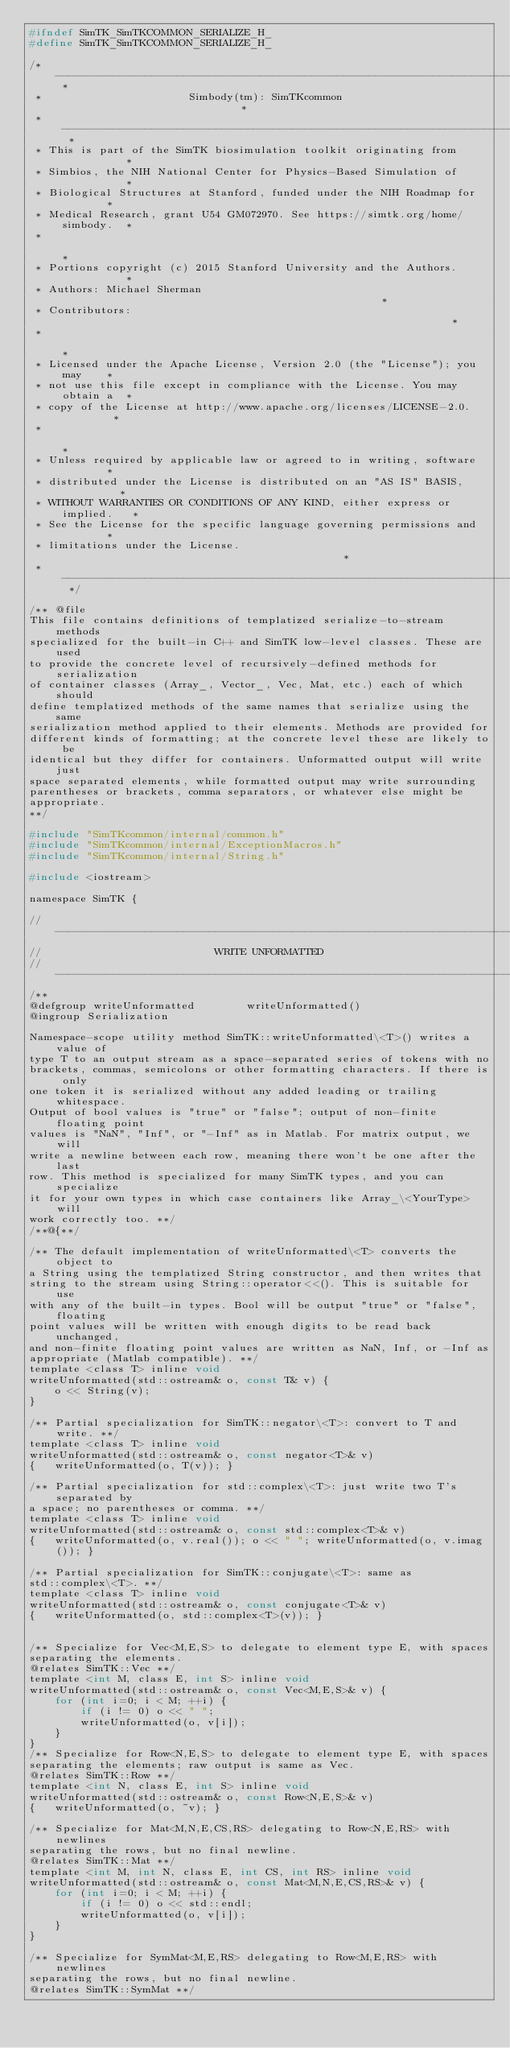<code> <loc_0><loc_0><loc_500><loc_500><_C_>#ifndef SimTK_SimTKCOMMON_SERIALIZE_H_
#define SimTK_SimTKCOMMON_SERIALIZE_H_

/* -------------------------------------------------------------------------- *
 *                       Simbody(tm): SimTKcommon                             *
 * -------------------------------------------------------------------------- *
 * This is part of the SimTK biosimulation toolkit originating from           *
 * Simbios, the NIH National Center for Physics-Based Simulation of           *
 * Biological Structures at Stanford, funded under the NIH Roadmap for        *
 * Medical Research, grant U54 GM072970. See https://simtk.org/home/simbody.  *
 *                                                                            *
 * Portions copyright (c) 2015 Stanford University and the Authors.           *
 * Authors: Michael Sherman                                                   *
 * Contributors:                                                              *
 *                                                                            *
 * Licensed under the Apache License, Version 2.0 (the "License"); you may    *
 * not use this file except in compliance with the License. You may obtain a  *
 * copy of the License at http://www.apache.org/licenses/LICENSE-2.0.         *
 *                                                                            *
 * Unless required by applicable law or agreed to in writing, software        *
 * distributed under the License is distributed on an "AS IS" BASIS,          *
 * WITHOUT WARRANTIES OR CONDITIONS OF ANY KIND, either express or implied.   *
 * See the License for the specific language governing permissions and        *
 * limitations under the License.                                             *
 * -------------------------------------------------------------------------- */

/** @file
This file contains definitions of templatized serialize-to-stream methods 
specialized for the built-in C++ and SimTK low-level classes. These are used
to provide the concrete level of recursively-defined methods for serialization
of container classes (Array_, Vector_, Vec, Mat, etc.) each of which should
define templatized methods of the same names that serialize using the same
serialization method applied to their elements. Methods are provided for 
different kinds of formatting; at the concrete level these are likely to be
identical but they differ for containers. Unformatted output will write just
space separated elements, while formatted output may write surrounding
parentheses or brackets, comma separators, or whatever else might be 
appropriate.
**/

#include "SimTKcommon/internal/common.h"
#include "SimTKcommon/internal/ExceptionMacros.h"
#include "SimTKcommon/internal/String.h"

#include <iostream>

namespace SimTK {

//------------------------------------------------------------------------------
//                           WRITE UNFORMATTED
//------------------------------------------------------------------------------
/**
@defgroup writeUnformatted        writeUnformatted()
@ingroup Serialization

Namespace-scope utility method SimTK::writeUnformatted\<T>() writes a value of
type T to an output stream as a space-separated series of tokens with no 
brackets, commas, semicolons or other formatting characters. If there is only 
one token it is serialized without any added leading or trailing whitespace.
Output of bool values is "true" or "false"; output of non-finite floating point
values is "NaN", "Inf", or "-Inf" as in Matlab. For matrix output, we will 
write a newline between each row, meaning there won't be one after the last 
row. This method is specialized for many SimTK types, and you can specialize
it for your own types in which case containers like Array_\<YourType> will 
work correctly too. **/
/**@{**/

/** The default implementation of writeUnformatted\<T> converts the object to
a String using the templatized String constructor, and then writes that
string to the stream using String::operator<<(). This is suitable for use
with any of the built-in types. Bool will be output "true" or "false", floating
point values will be written with enough digits to be read back unchanged,
and non-finite floating point values are written as NaN, Inf, or -Inf as 
appropriate (Matlab compatible). **/
template <class T> inline void
writeUnformatted(std::ostream& o, const T& v) {
    o << String(v);
}

/** Partial specialization for SimTK::negator\<T>: convert to T and write. **/
template <class T> inline void
writeUnformatted(std::ostream& o, const negator<T>& v) 
{   writeUnformatted(o, T(v)); }

/** Partial specialization for std::complex\<T>: just write two T's separated by
a space; no parentheses or comma. **/
template <class T> inline void
writeUnformatted(std::ostream& o, const std::complex<T>& v) 
{   writeUnformatted(o, v.real()); o << " "; writeUnformatted(o, v.imag()); }

/** Partial specialization for SimTK::conjugate\<T>: same as 
std::complex\<T>. **/
template <class T> inline void
writeUnformatted(std::ostream& o, const conjugate<T>& v) 
{   writeUnformatted(o, std::complex<T>(v)); }


/** Specialize for Vec<M,E,S> to delegate to element type E, with spaces
separating the elements. 
@relates SimTK::Vec **/
template <int M, class E, int S> inline void
writeUnformatted(std::ostream& o, const Vec<M,E,S>& v) {
    for (int i=0; i < M; ++i) {
        if (i != 0) o << " ";
        writeUnformatted(o, v[i]);
    }
}   
/** Specialize for Row<N,E,S> to delegate to element type E, with spaces
separating the elements; raw output is same as Vec. 
@relates SimTK::Row **/
template <int N, class E, int S> inline void
writeUnformatted(std::ostream& o, const Row<N,E,S>& v) 
{   writeUnformatted(o, ~v); }

/** Specialize for Mat<M,N,E,CS,RS> delegating to Row<N,E,RS> with newlines
separating the rows, but no final newline.
@relates SimTK::Mat **/
template <int M, int N, class E, int CS, int RS> inline void
writeUnformatted(std::ostream& o, const Mat<M,N,E,CS,RS>& v) {
    for (int i=0; i < M; ++i) {
        if (i != 0) o << std::endl;
        writeUnformatted(o, v[i]);
    }
} 

/** Specialize for SymMat<M,E,RS> delegating to Row<M,E,RS> with newlines
separating the rows, but no final newline.
@relates SimTK::SymMat **/</code> 